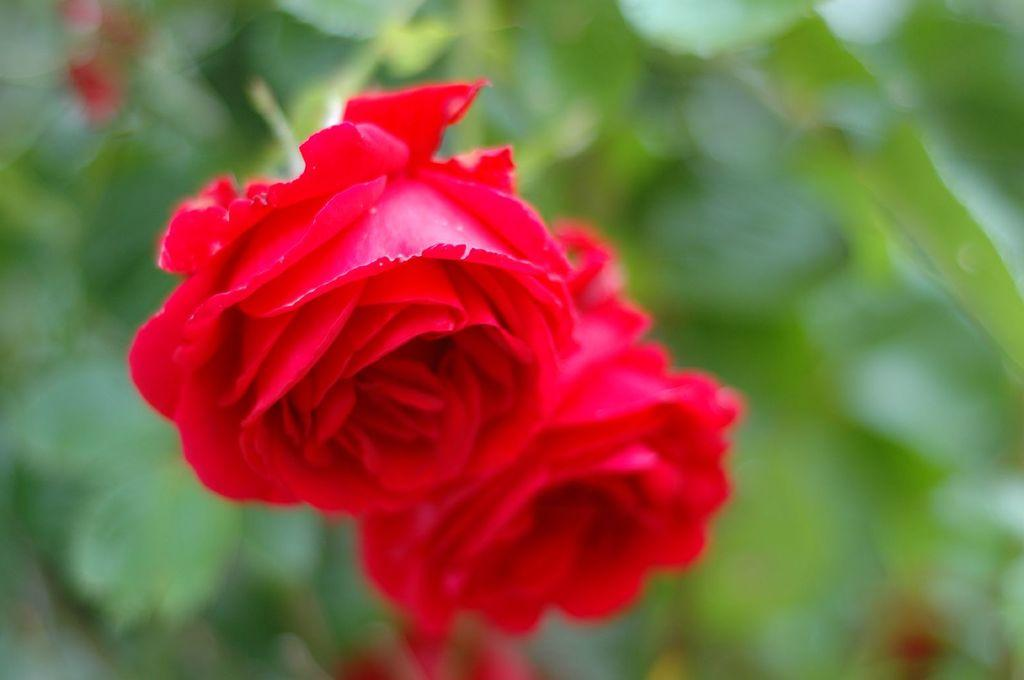What type of flowers are present in the image? There are two rose flowers in the image. Can you describe the background of the image? The background of the image is blurred. What type of hat is the tiger wearing in the image? There is no tiger or hat present in the image; it features two rose flowers with a blurred background. 